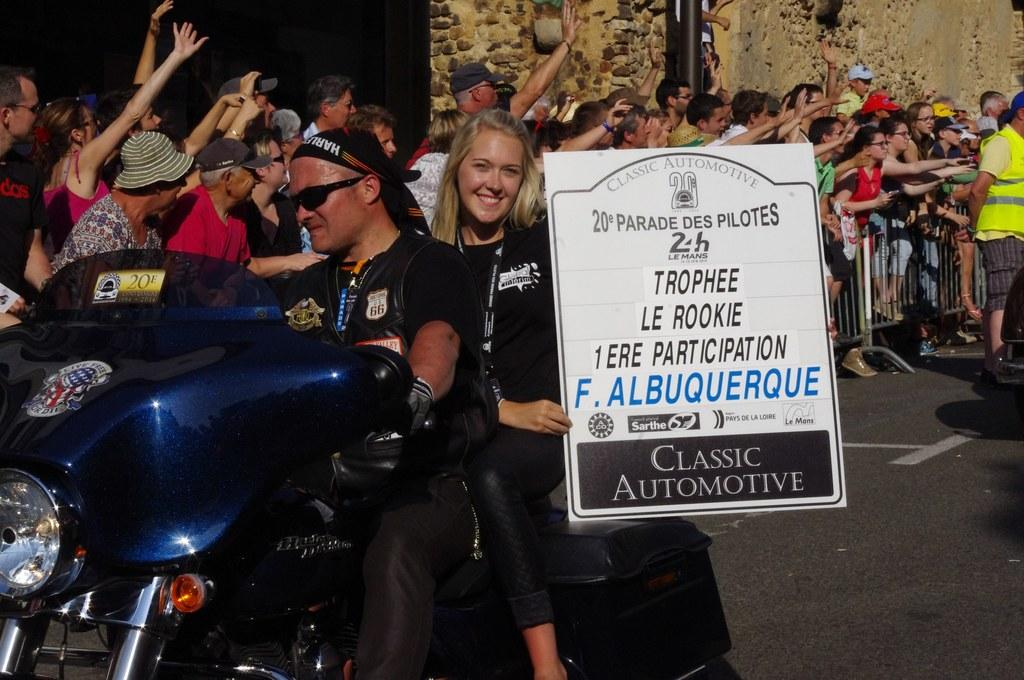How many people are in the image? There are two people in the image, a man and a woman. What are the man and woman doing in the image? The man and woman are on a bike together. What is the woman holding in the image? There is a woman holding a board in the image. What can be seen in the background of the image? There are people standing, a pole, and a wall in the background of the image. What type of suit is the friend wearing in the image? There is no friend present in the image, and no one is wearing a suit. 